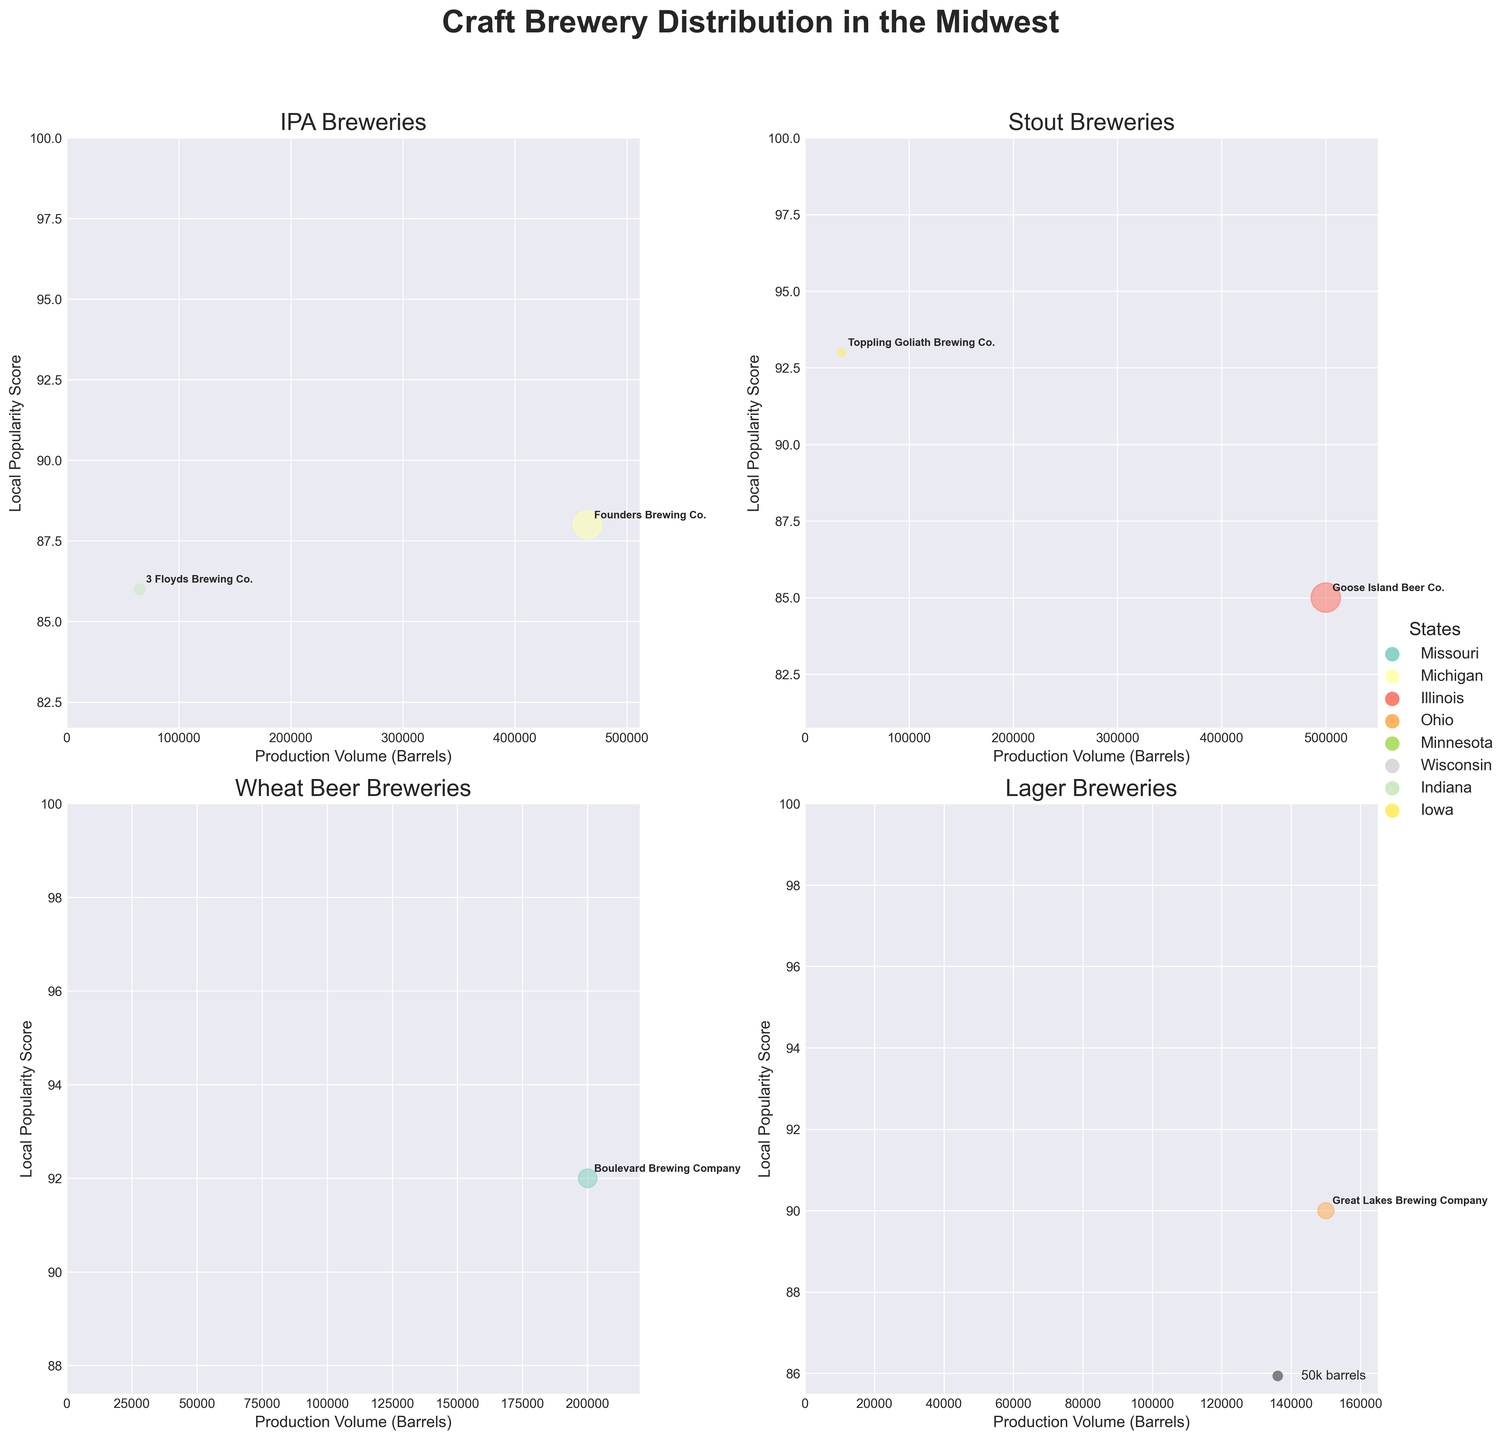What is the title of the figure? The title is located at the top of the figure and is prominently displayed for easy identification.
Answer: Craft Brewery Distribution in the Midwest Which beer style has the brewery with the highest production volume? By examining the subplots, the brewery with the highest production volume is in the Stout subplot, which indicates that it represents Goose Island Beer Co. with 500,000 barrels.
Answer: Stout How many breweries are shown in the Lager subplot? To find the number of breweries in the Lager subplot, count the data points or annotations within the specific Lager chart. There is only one data point annotated as Great Lakes Brewing Company.
Answer: 1 Which brewer has the highest local popularity score within the Wheat Beer subplot? Check the Wheat Beer subplot for the highest y-axis value that represents the Local Popularity Score. The highest score is 92, corresponding to Boulevard Brewing Company.
Answer: Boulevard Brewing Company What is the production volume of Founders Brewing Co.? Locate Founders Brewing Co. in the IPA subplot and check the corresponding x-axis value (production volume). Founders Brewing Co. has a production volume of 465,000 barrels.
Answer: 465,000 barrels Compare the production volumes of Schlafly Beer and Surly Brewing Company. Which one is greater? Identify Schlafly Beer in the Amber Ale subplot and Surly Brewing Company in the Porter subplot. Schlafly Beer has a production volume of 60,000 barrels, while Surly Brewing Company has a production volume of 95,000 barrels. Therefore, Surly Brewing Company has a greater production volume.
Answer: Surly Brewing Company Which state has breweries represented in all of the subplots? To answer this, identify the breweries and their states in each subplot. The subplots are IPA, Stout, Wheat Beer, and Lager. Upon inspection, Michigan appears in the IPA (Founders Brewing Co.) and Pale Ale (Bell's Brewery) subplots, indicating it is not present in all subplots. No individual state is present in all four subplots.
Answer: None What is the relationship between production volume and local popularity for Porter breweries? Analyze the Porter subplot to see the correlation between x-axis (production volume) and y-axis (local popularity score). The higher production volume for Surly Brewing Company correlates with a high local popularity score of 91 points.
Answer: Higher production volume correlates with high popularity Which brewery represents the smallest bubble size in the Imperial Stout subplot? In the Imperial Stout subplot, look for the smallest bubble which indicates the smallest production volume. This bubble represents Toppling Goliath Brewing Co. with a production volume of 35,000 barrels.
Answer: Toppling Goliath Brewing Co What is the average local popularity score of the breweries in the Stout subplot? Identify the Local Popularity Scores in the Stout subplot, which are 85 for Goose Island Beer Co. Since there is only one brewery in this subplot, the average is the same as the individual score.
Answer: 85 